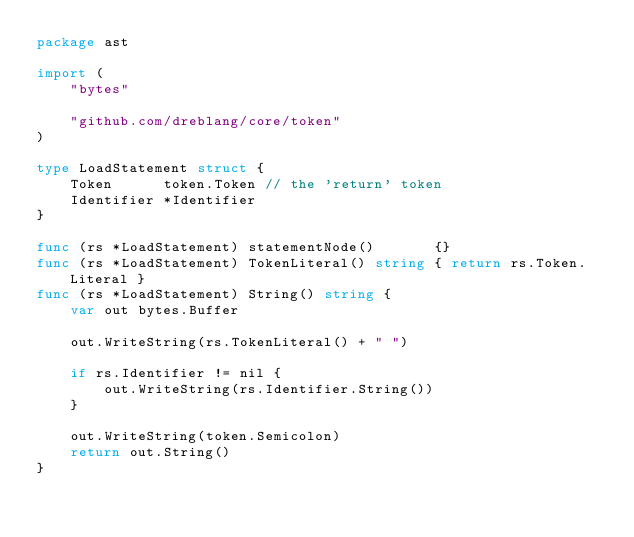Convert code to text. <code><loc_0><loc_0><loc_500><loc_500><_Go_>package ast

import (
	"bytes"

	"github.com/dreblang/core/token"
)

type LoadStatement struct {
	Token      token.Token // the 'return' token
	Identifier *Identifier
}

func (rs *LoadStatement) statementNode()       {}
func (rs *LoadStatement) TokenLiteral() string { return rs.Token.Literal }
func (rs *LoadStatement) String() string {
	var out bytes.Buffer

	out.WriteString(rs.TokenLiteral() + " ")

	if rs.Identifier != nil {
		out.WriteString(rs.Identifier.String())
	}

	out.WriteString(token.Semicolon)
	return out.String()
}
</code> 